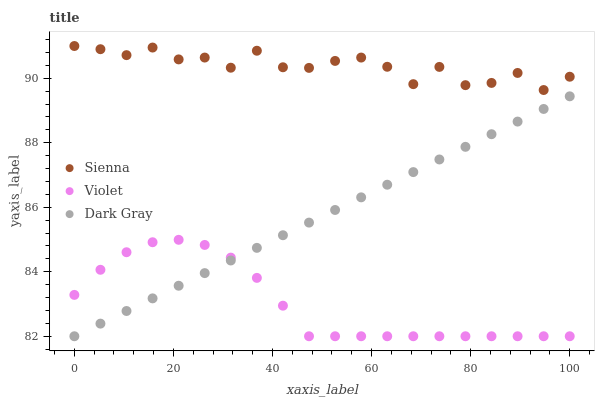Does Violet have the minimum area under the curve?
Answer yes or no. Yes. Does Sienna have the maximum area under the curve?
Answer yes or no. Yes. Does Dark Gray have the minimum area under the curve?
Answer yes or no. No. Does Dark Gray have the maximum area under the curve?
Answer yes or no. No. Is Dark Gray the smoothest?
Answer yes or no. Yes. Is Sienna the roughest?
Answer yes or no. Yes. Is Violet the smoothest?
Answer yes or no. No. Is Violet the roughest?
Answer yes or no. No. Does Dark Gray have the lowest value?
Answer yes or no. Yes. Does Sienna have the highest value?
Answer yes or no. Yes. Does Dark Gray have the highest value?
Answer yes or no. No. Is Violet less than Sienna?
Answer yes or no. Yes. Is Sienna greater than Dark Gray?
Answer yes or no. Yes. Does Dark Gray intersect Violet?
Answer yes or no. Yes. Is Dark Gray less than Violet?
Answer yes or no. No. Is Dark Gray greater than Violet?
Answer yes or no. No. Does Violet intersect Sienna?
Answer yes or no. No. 